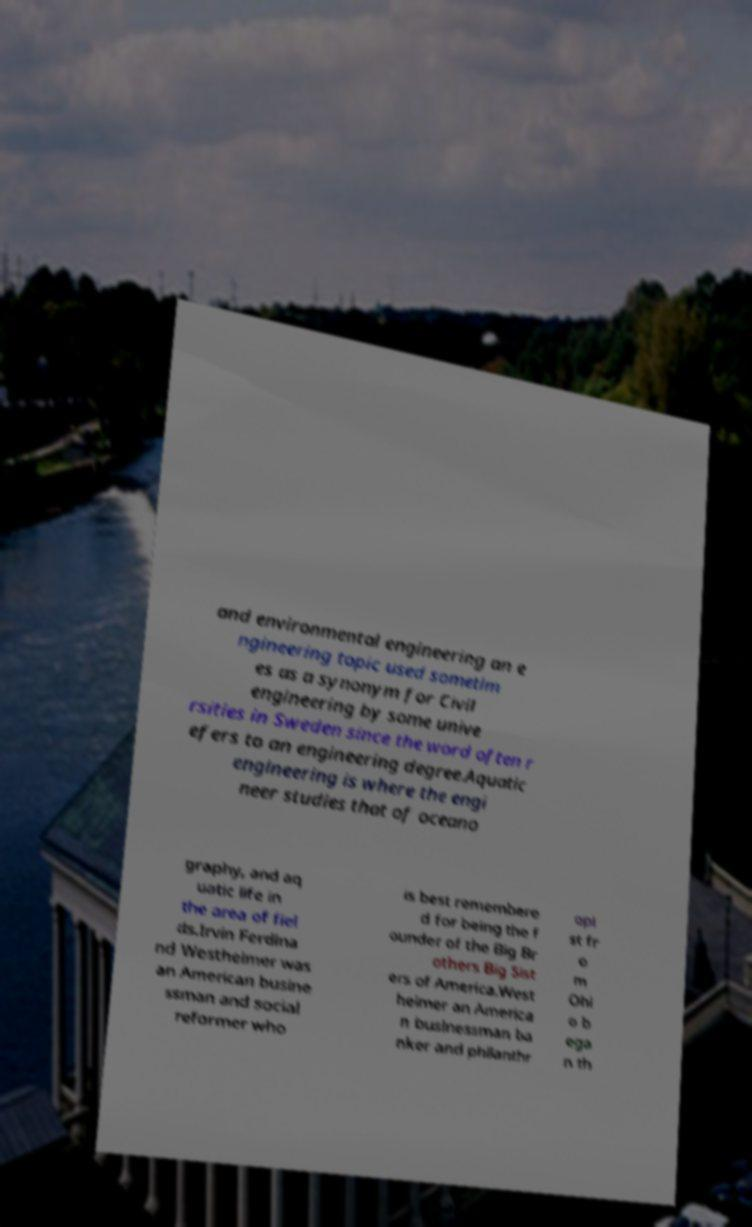Please identify and transcribe the text found in this image. and environmental engineering an e ngineering topic used sometim es as a synonym for Civil engineering by some unive rsities in Sweden since the word often r efers to an engineering degree.Aquatic engineering is where the engi neer studies that of oceano graphy, and aq uatic life in the area of fiel ds.Irvin Ferdina nd Westheimer was an American busine ssman and social reformer who is best remembere d for being the f ounder of the Big Br others Big Sist ers of America.West heimer an America n businessman ba nker and philanthr opi st fr o m Ohi o b ega n th 